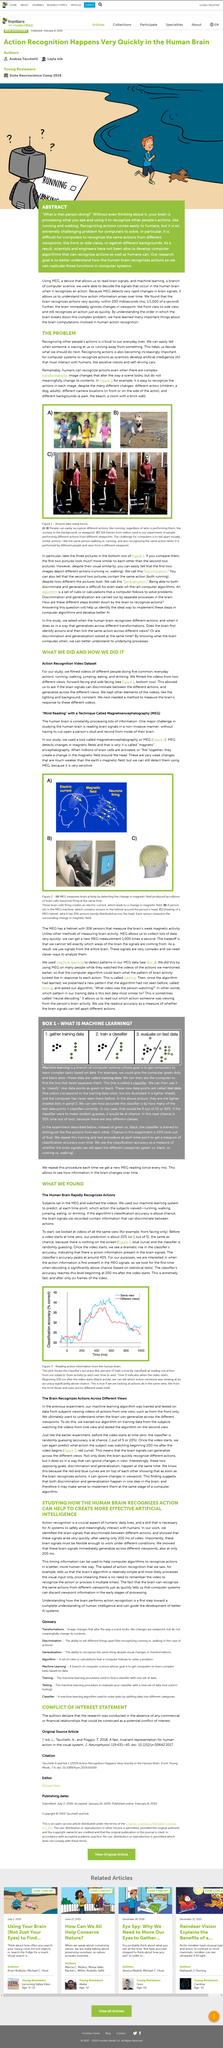List a handful of essential elements in this visual. The dog in image B is running. The images in C are stills taken from videos, with the source of these images being video footage. Understanding the human brain is a significant challenge, as it is difficult to read brain signals in a non-invasive manner. MEG is a tool that utilizes magnetic fields to detect changes in the environment, providing valuable information for a variety of applications. During the experiment, brain signals were recorded. 